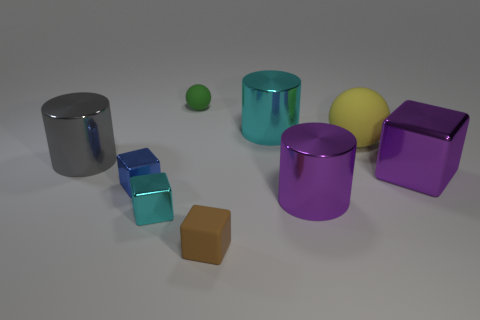There is a brown object that is the same shape as the small cyan metallic thing; what is its material?
Offer a very short reply. Rubber. How many yellow things are on the right side of the large yellow object?
Give a very brief answer. 0. Is the number of big cyan shiny objects that are left of the big gray shiny cylinder less than the number of cubes left of the purple cube?
Provide a short and direct response. Yes. There is a large purple object right of the large sphere right of the large shiny object on the left side of the small brown thing; what is its shape?
Provide a short and direct response. Cube. There is a rubber thing that is behind the tiny brown object and right of the tiny green thing; what is its shape?
Your response must be concise. Sphere. Is there a small green object made of the same material as the green ball?
Give a very brief answer. No. There is a metal cylinder that is the same color as the large block; what size is it?
Keep it short and to the point. Large. The sphere that is right of the small brown rubber block is what color?
Make the answer very short. Yellow. There is a big cyan metal thing; does it have the same shape as the small matte object in front of the tiny green sphere?
Ensure brevity in your answer.  No. Are there any cylinders that have the same color as the big block?
Offer a terse response. Yes. 